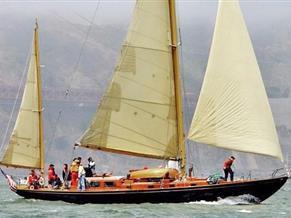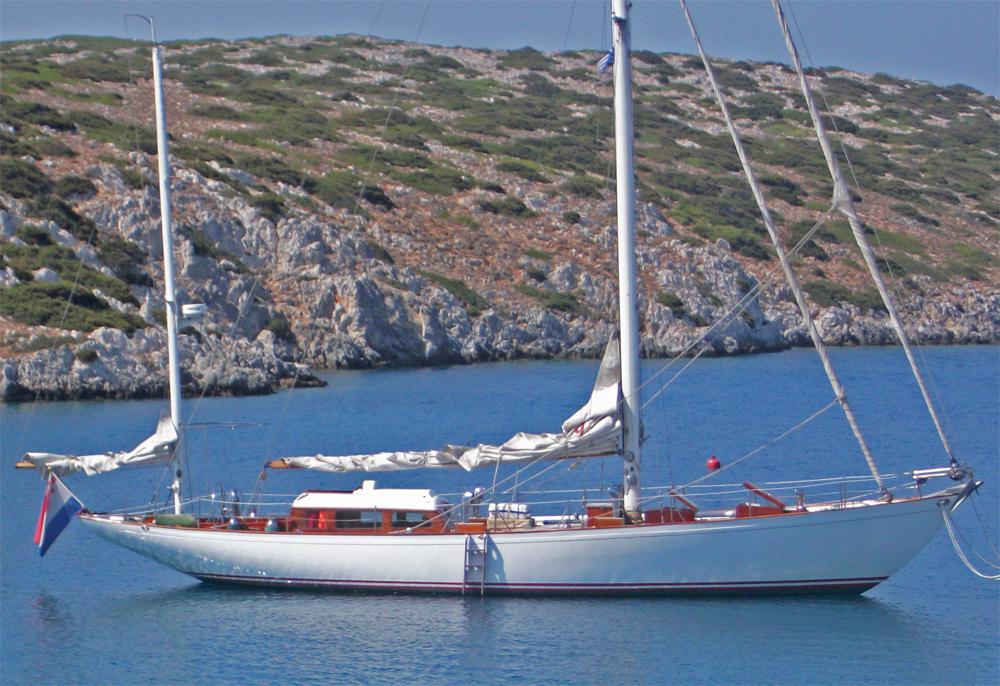The first image is the image on the left, the second image is the image on the right. Evaluate the accuracy of this statement regarding the images: "There is no more than 1 raised sail in the right image.". Is it true? Answer yes or no. Yes. The first image is the image on the left, the second image is the image on the right. Analyze the images presented: Is the assertion "One of the images has a large group of people all wearing white shirts." valid? Answer yes or no. No. 